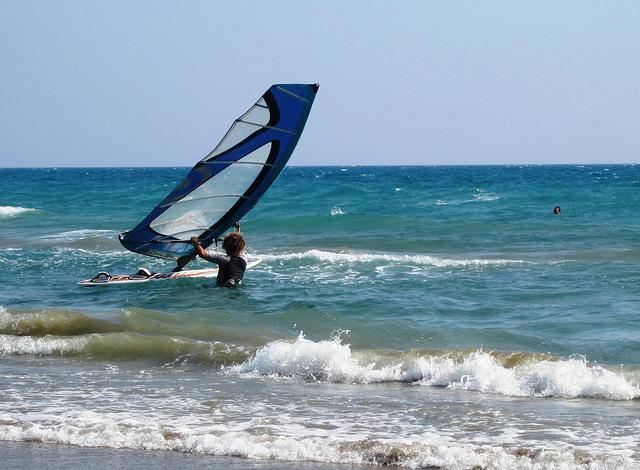What is he doing? Please explain your reasoning. boarding board. He's boarding the board. 